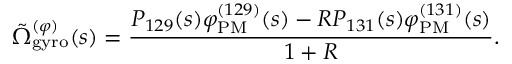<formula> <loc_0><loc_0><loc_500><loc_500>\tilde { \Omega } _ { g y r o } ^ { ( \varphi ) } ( s ) = \frac { P _ { 1 2 9 } ( s ) \varphi _ { P M } ^ { ( 1 2 9 ) } ( s ) - R P _ { 1 3 1 } ( s ) \varphi _ { P M } ^ { ( 1 3 1 ) } ( s ) } { 1 + R } .</formula> 